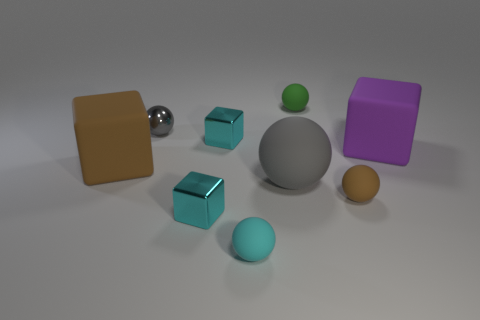Subtract 2 spheres. How many spheres are left? 3 Subtract all brown balls. How many balls are left? 4 Subtract all brown spheres. How many spheres are left? 4 Subtract all purple spheres. Subtract all cyan cylinders. How many spheres are left? 5 Subtract all balls. How many objects are left? 4 Subtract 0 gray cubes. How many objects are left? 9 Subtract all tiny purple shiny cylinders. Subtract all tiny metal balls. How many objects are left? 8 Add 5 metallic spheres. How many metallic spheres are left? 6 Add 9 brown rubber cubes. How many brown rubber cubes exist? 10 